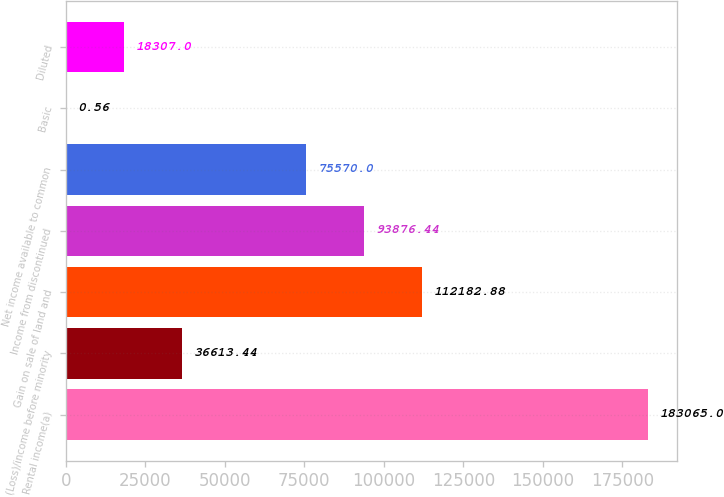<chart> <loc_0><loc_0><loc_500><loc_500><bar_chart><fcel>Rental income(a)<fcel>(Loss)/income before minority<fcel>Gain on sale of land and<fcel>Income from discontinued<fcel>Net income available to common<fcel>Basic<fcel>Diluted<nl><fcel>183065<fcel>36613.4<fcel>112183<fcel>93876.4<fcel>75570<fcel>0.56<fcel>18307<nl></chart> 